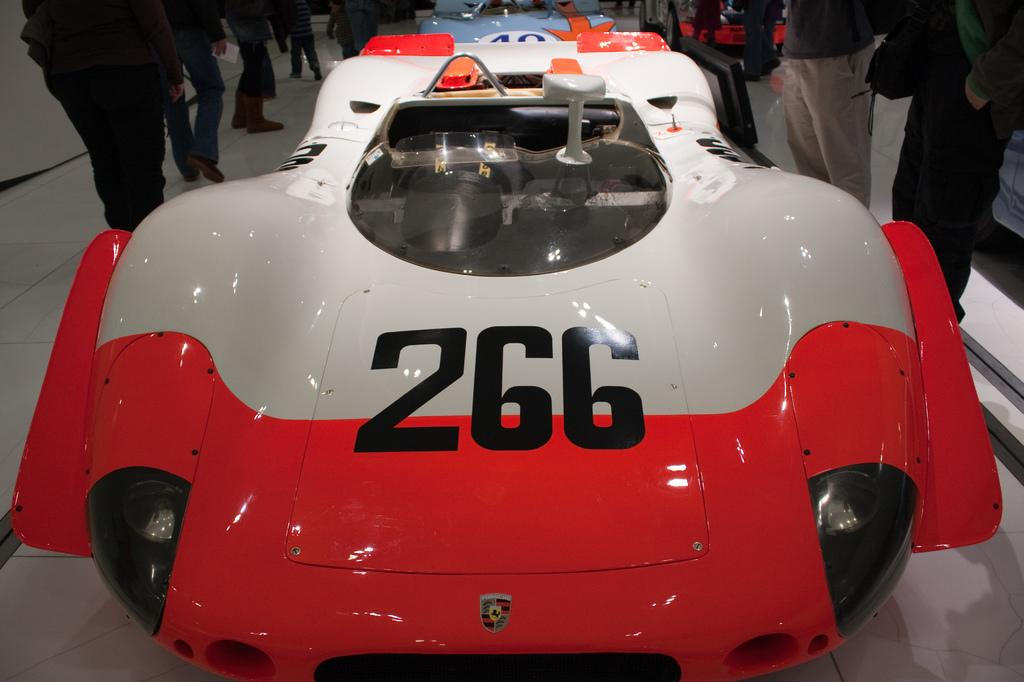What is the main subject in the front of the image? There is a car in the front of the image. What can be seen in the background of the image? There are people standing in the background of the image. What is the surface on which the car and people are standing? The bottom of the image includes the floor. What is the weight of the animal in the image? There is no animal present in the image, so it is not possible to determine its weight. 